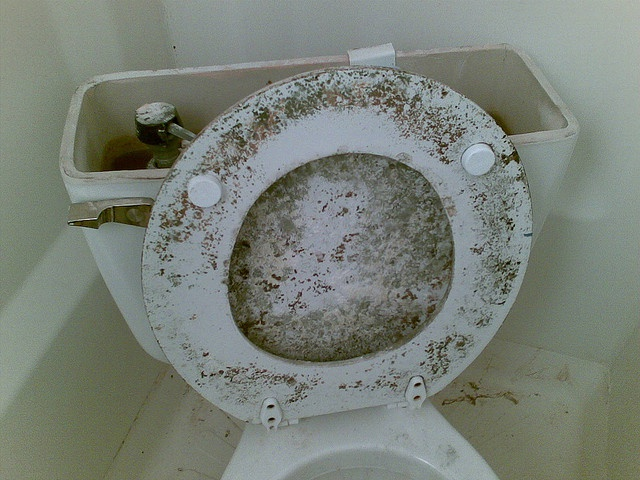Describe the objects in this image and their specific colors. I can see a toilet in gray, darkgray, and black tones in this image. 